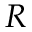Convert formula to latex. <formula><loc_0><loc_0><loc_500><loc_500>R</formula> 